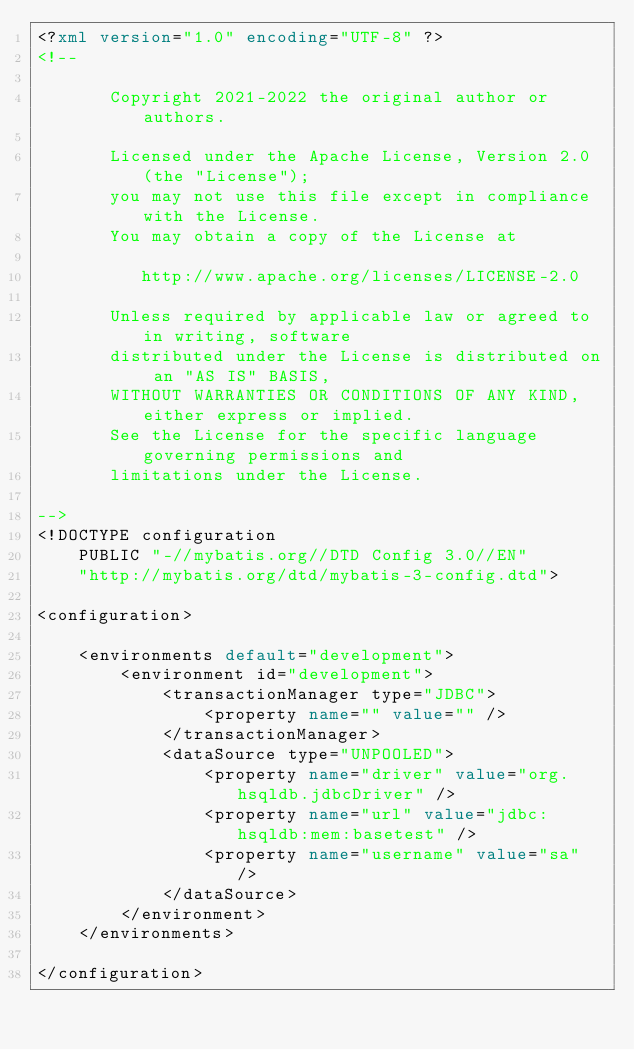<code> <loc_0><loc_0><loc_500><loc_500><_XML_><?xml version="1.0" encoding="UTF-8" ?>
<!--

       Copyright 2021-2022 the original author or authors.

       Licensed under the Apache License, Version 2.0 (the "License");
       you may not use this file except in compliance with the License.
       You may obtain a copy of the License at

          http://www.apache.org/licenses/LICENSE-2.0

       Unless required by applicable law or agreed to in writing, software
       distributed under the License is distributed on an "AS IS" BASIS,
       WITHOUT WARRANTIES OR CONDITIONS OF ANY KIND, either express or implied.
       See the License for the specific language governing permissions and
       limitations under the License.

-->
<!DOCTYPE configuration
    PUBLIC "-//mybatis.org//DTD Config 3.0//EN"
    "http://mybatis.org/dtd/mybatis-3-config.dtd">

<configuration>

    <environments default="development">
        <environment id="development">
            <transactionManager type="JDBC">
                <property name="" value="" />
            </transactionManager>
            <dataSource type="UNPOOLED">
                <property name="driver" value="org.hsqldb.jdbcDriver" />
                <property name="url" value="jdbc:hsqldb:mem:basetest" />
                <property name="username" value="sa" />
            </dataSource>
        </environment>
    </environments>

</configuration>
</code> 